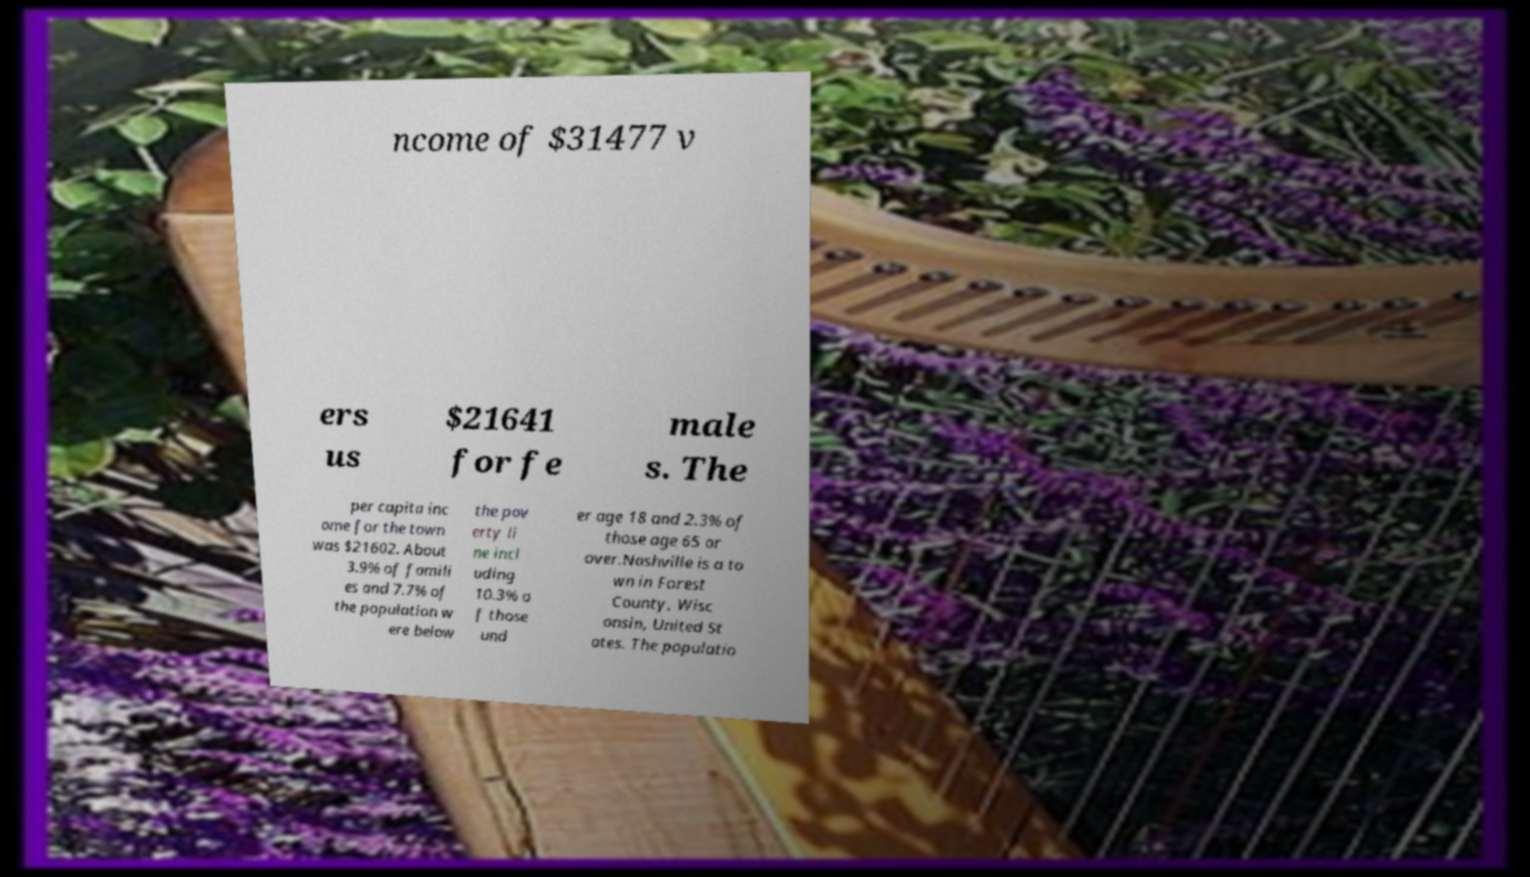Can you read and provide the text displayed in the image?This photo seems to have some interesting text. Can you extract and type it out for me? ncome of $31477 v ers us $21641 for fe male s. The per capita inc ome for the town was $21602. About 3.9% of famili es and 7.7% of the population w ere below the pov erty li ne incl uding 10.3% o f those und er age 18 and 2.3% of those age 65 or over.Nashville is a to wn in Forest County, Wisc onsin, United St ates. The populatio 